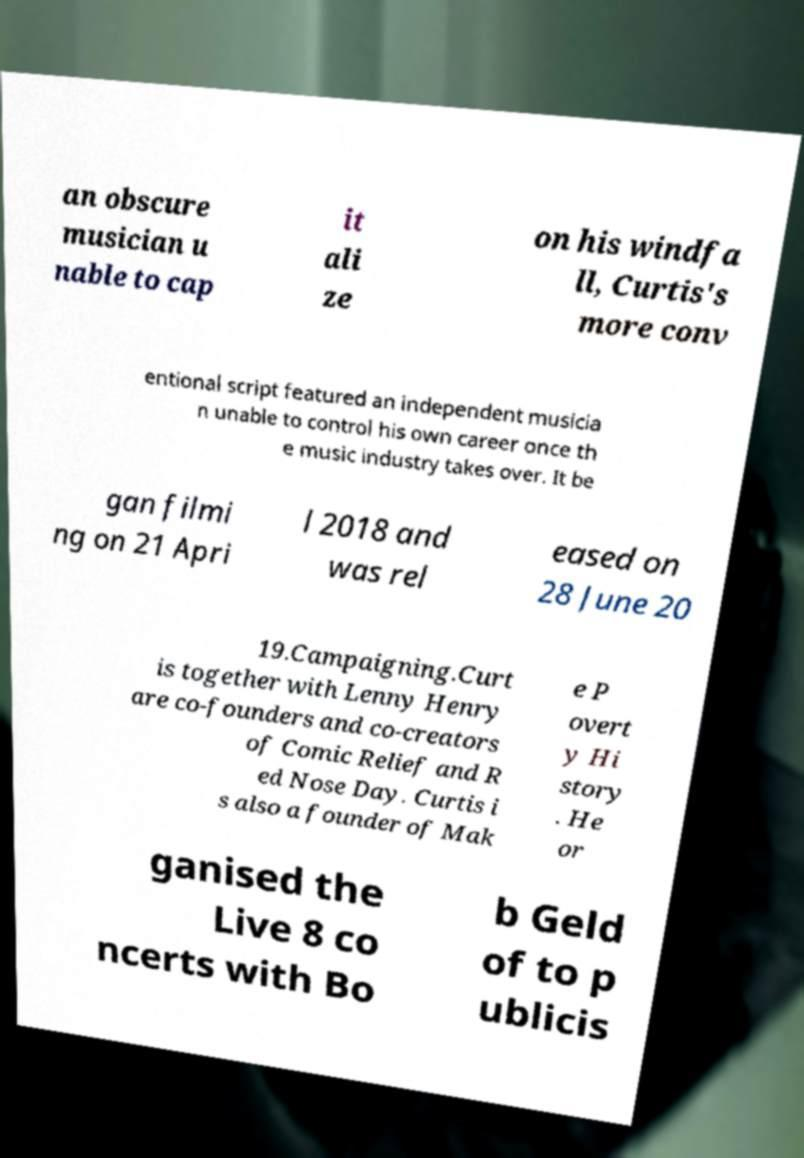I need the written content from this picture converted into text. Can you do that? an obscure musician u nable to cap it ali ze on his windfa ll, Curtis's more conv entional script featured an independent musicia n unable to control his own career once th e music industry takes over. It be gan filmi ng on 21 Apri l 2018 and was rel eased on 28 June 20 19.Campaigning.Curt is together with Lenny Henry are co-founders and co-creators of Comic Relief and R ed Nose Day. Curtis i s also a founder of Mak e P overt y Hi story . He or ganised the Live 8 co ncerts with Bo b Geld of to p ublicis 